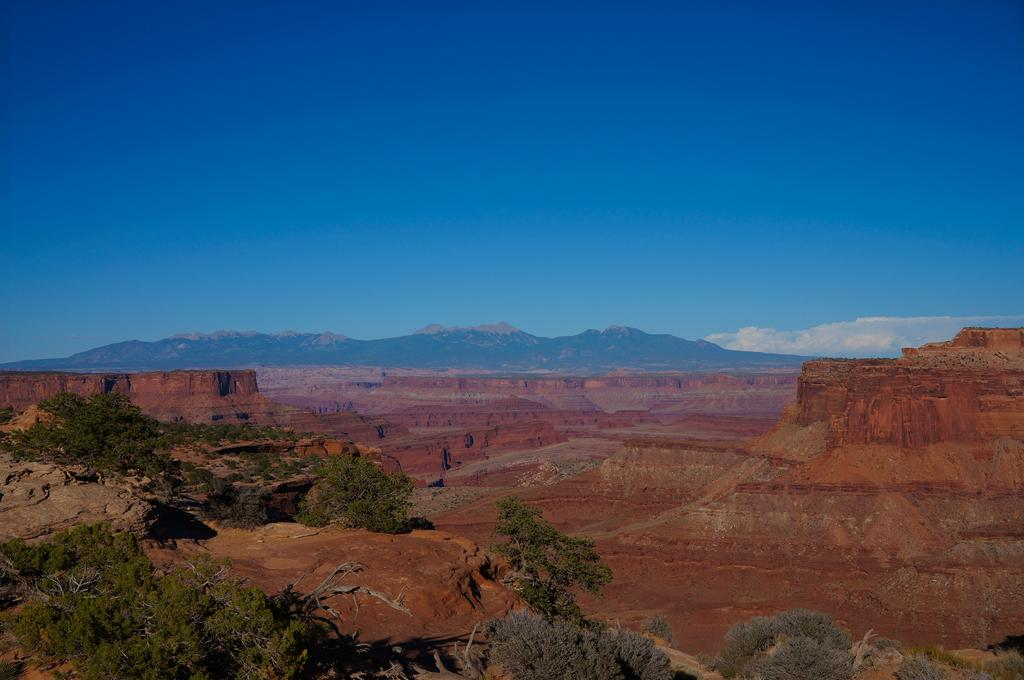What type of natural features can be seen in the image? There are trees, hills, and rocks visible in the image. What is visible in the background of the image? The sky is visible in the image. What can be seen in the sky? There are clouds in the sky. Where is the mine located in the image? There is no mine present in the image. What type of cord can be seen connecting the trees in the image? There is no cord visible connecting the trees in the image. 